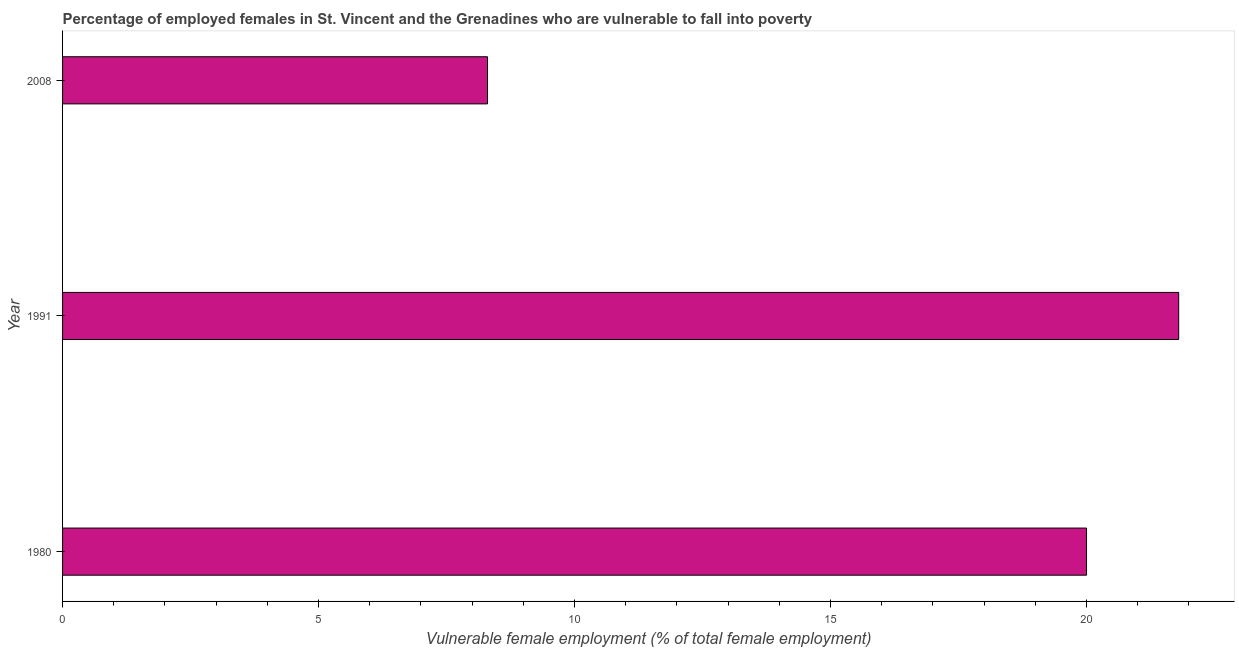What is the title of the graph?
Your response must be concise. Percentage of employed females in St. Vincent and the Grenadines who are vulnerable to fall into poverty. What is the label or title of the X-axis?
Give a very brief answer. Vulnerable female employment (% of total female employment). What is the percentage of employed females who are vulnerable to fall into poverty in 2008?
Keep it short and to the point. 8.3. Across all years, what is the maximum percentage of employed females who are vulnerable to fall into poverty?
Offer a very short reply. 21.8. Across all years, what is the minimum percentage of employed females who are vulnerable to fall into poverty?
Your answer should be very brief. 8.3. In which year was the percentage of employed females who are vulnerable to fall into poverty maximum?
Provide a succinct answer. 1991. In which year was the percentage of employed females who are vulnerable to fall into poverty minimum?
Your response must be concise. 2008. What is the sum of the percentage of employed females who are vulnerable to fall into poverty?
Offer a very short reply. 50.1. What is the difference between the percentage of employed females who are vulnerable to fall into poverty in 1991 and 2008?
Your response must be concise. 13.5. What is the median percentage of employed females who are vulnerable to fall into poverty?
Keep it short and to the point. 20. In how many years, is the percentage of employed females who are vulnerable to fall into poverty greater than 17 %?
Provide a succinct answer. 2. Do a majority of the years between 2008 and 1980 (inclusive) have percentage of employed females who are vulnerable to fall into poverty greater than 3 %?
Make the answer very short. Yes. What is the ratio of the percentage of employed females who are vulnerable to fall into poverty in 1980 to that in 2008?
Your answer should be compact. 2.41. Is the percentage of employed females who are vulnerable to fall into poverty in 1980 less than that in 2008?
Ensure brevity in your answer.  No. Is the sum of the percentage of employed females who are vulnerable to fall into poverty in 1980 and 1991 greater than the maximum percentage of employed females who are vulnerable to fall into poverty across all years?
Offer a terse response. Yes. How many years are there in the graph?
Keep it short and to the point. 3. What is the Vulnerable female employment (% of total female employment) in 1980?
Ensure brevity in your answer.  20. What is the Vulnerable female employment (% of total female employment) in 1991?
Make the answer very short. 21.8. What is the Vulnerable female employment (% of total female employment) in 2008?
Provide a short and direct response. 8.3. What is the difference between the Vulnerable female employment (% of total female employment) in 1980 and 1991?
Offer a terse response. -1.8. What is the difference between the Vulnerable female employment (% of total female employment) in 1980 and 2008?
Your answer should be compact. 11.7. What is the ratio of the Vulnerable female employment (% of total female employment) in 1980 to that in 1991?
Provide a short and direct response. 0.92. What is the ratio of the Vulnerable female employment (% of total female employment) in 1980 to that in 2008?
Keep it short and to the point. 2.41. What is the ratio of the Vulnerable female employment (% of total female employment) in 1991 to that in 2008?
Your answer should be compact. 2.63. 